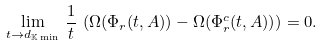<formula> <loc_0><loc_0><loc_500><loc_500>\lim _ { t \to d _ { \mathbb { K } \min } } \, \frac { 1 } { t } \, \left ( \Omega ( \Phi _ { r } ( t , A ) ) - \Omega ( \Phi ^ { c } _ { r } ( t , A ) ) \right ) = 0 .</formula> 